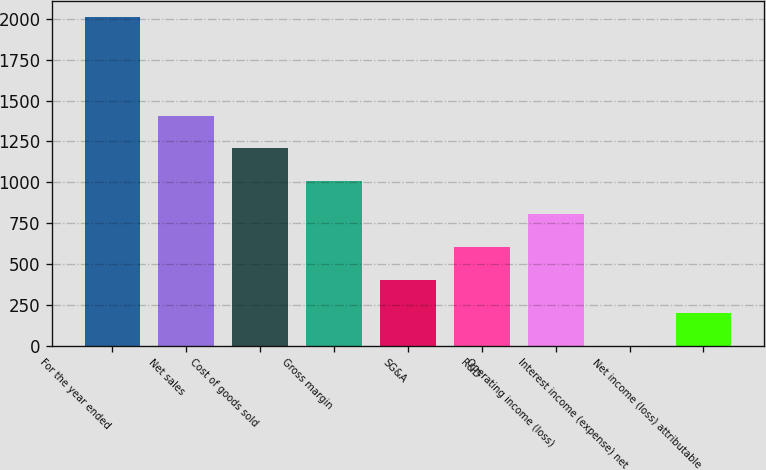Convert chart to OTSL. <chart><loc_0><loc_0><loc_500><loc_500><bar_chart><fcel>For the year ended<fcel>Net sales<fcel>Cost of goods sold<fcel>Gross margin<fcel>SG&A<fcel>R&D<fcel>Operating income (loss)<fcel>Interest income (expense) net<fcel>Net income (loss) attributable<nl><fcel>2011<fcel>1408<fcel>1207<fcel>1006<fcel>403<fcel>604<fcel>805<fcel>1<fcel>202<nl></chart> 